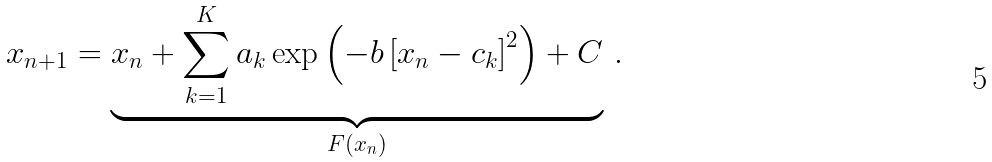Convert formula to latex. <formula><loc_0><loc_0><loc_500><loc_500>x _ { n + 1 } = \underbrace { x _ { n } + \sum _ { k = 1 } ^ { K } a _ { k } \exp \left ( - b \left [ { x } _ { n } - { c } _ { k } \right ] ^ { 2 } \right ) + C } _ { F ( { x } _ { n } ) } \, .</formula> 